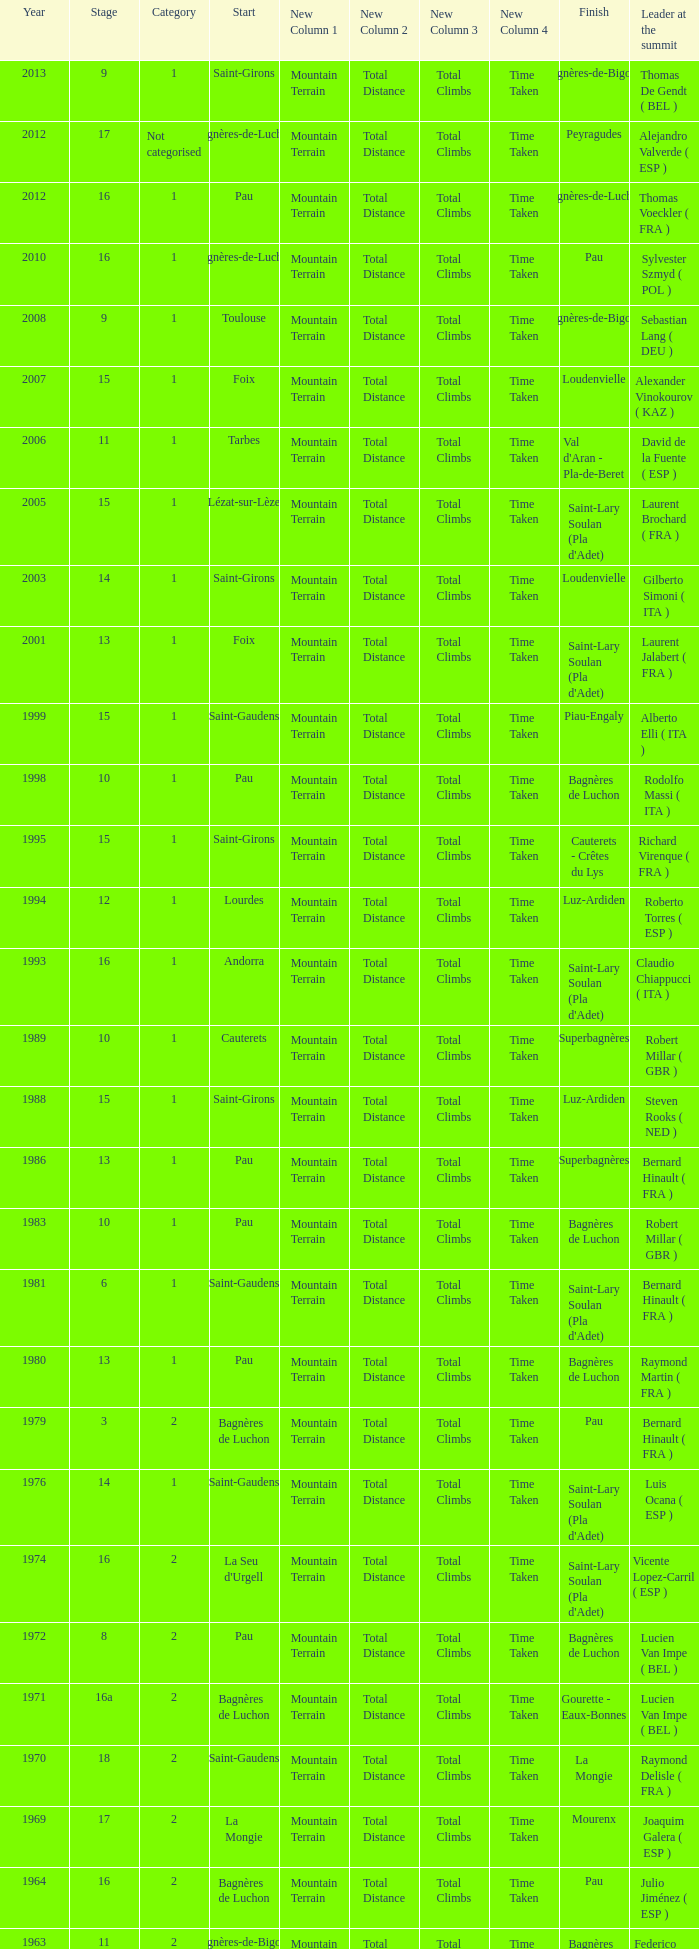What stage has a start of saint-girons in 1988? 15.0. 